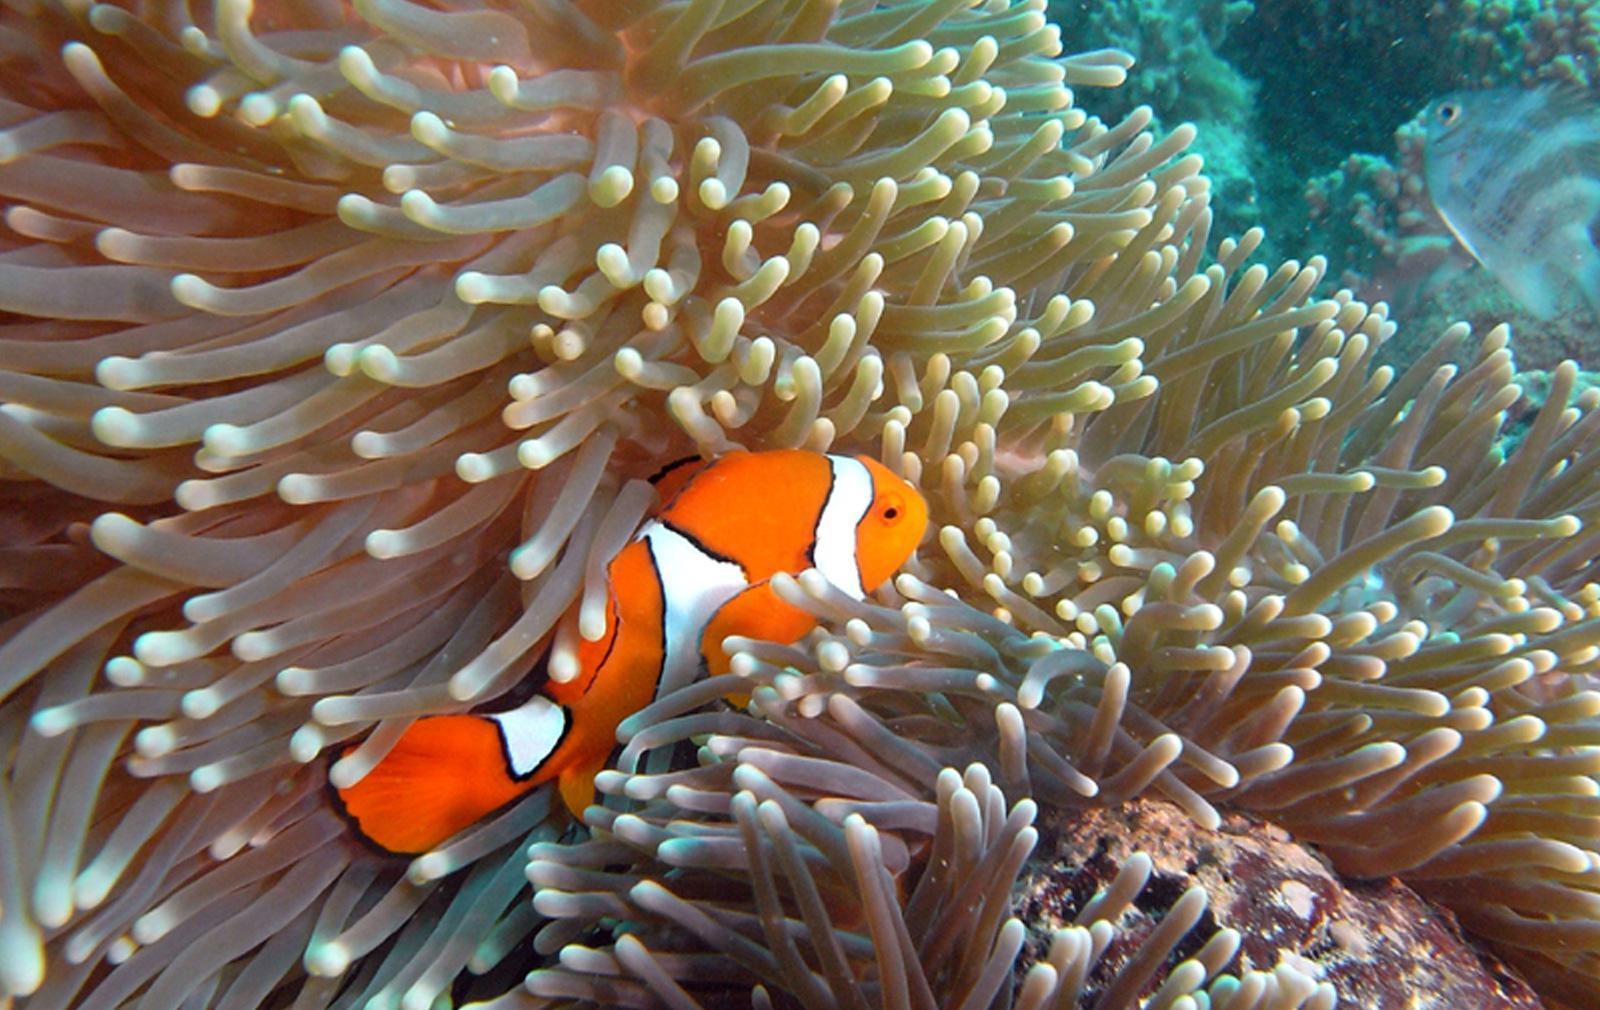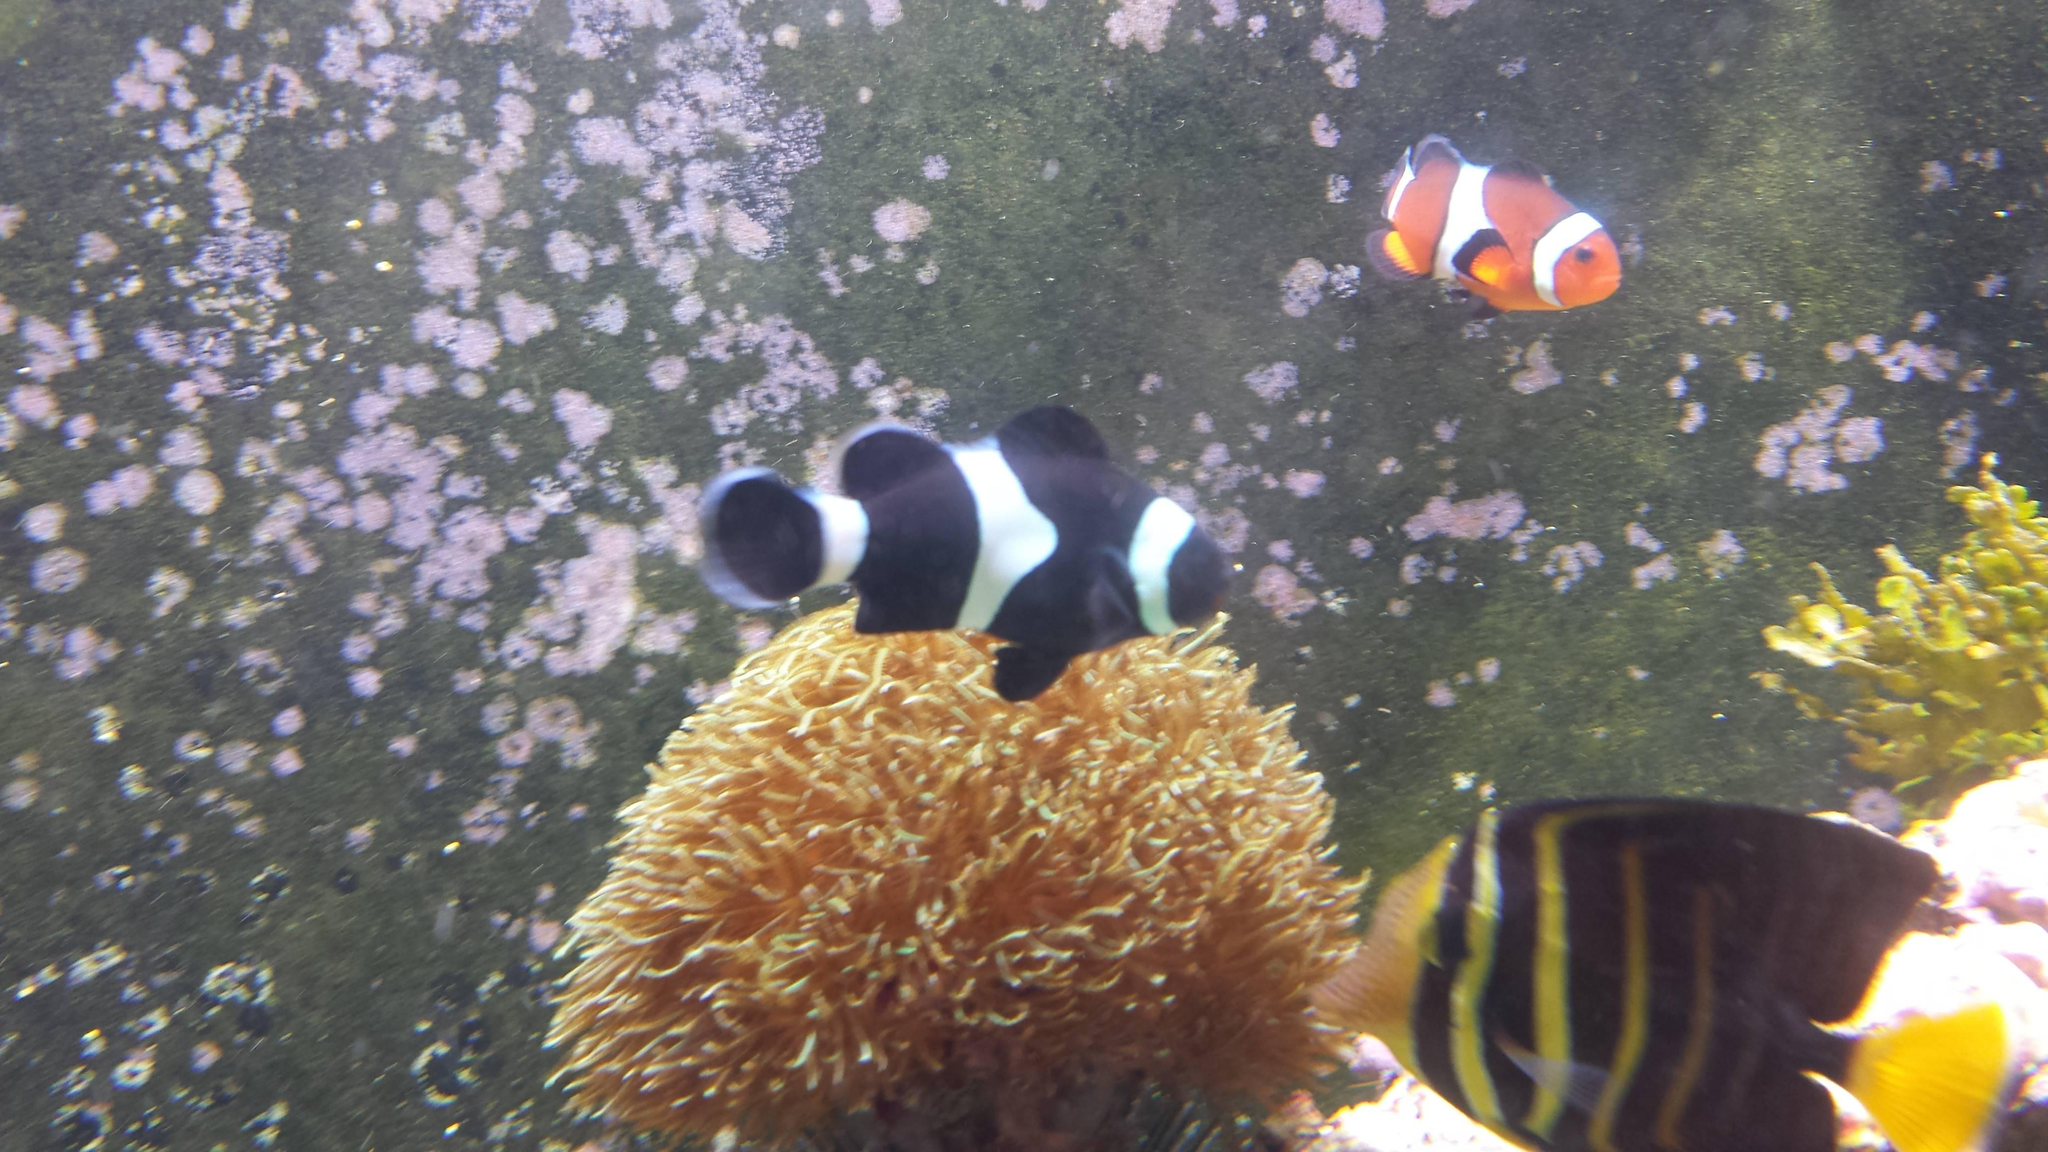The first image is the image on the left, the second image is the image on the right. Examine the images to the left and right. Is the description "An image includes two orange clownfish." accurate? Answer yes or no. No. 